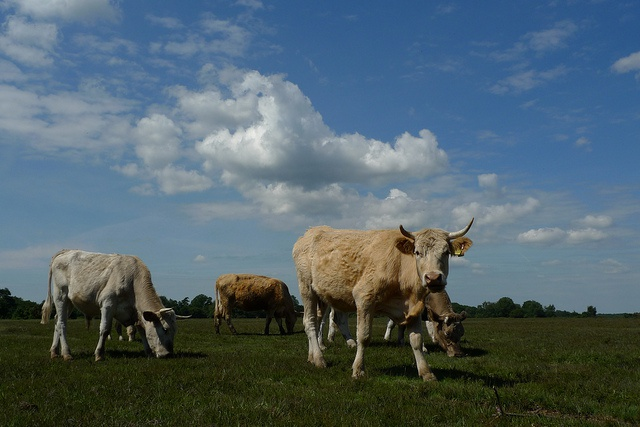Describe the objects in this image and their specific colors. I can see cow in gray, black, tan, and olive tones, cow in gray, black, and darkgray tones, cow in gray, black, olive, and maroon tones, and cow in gray and black tones in this image. 